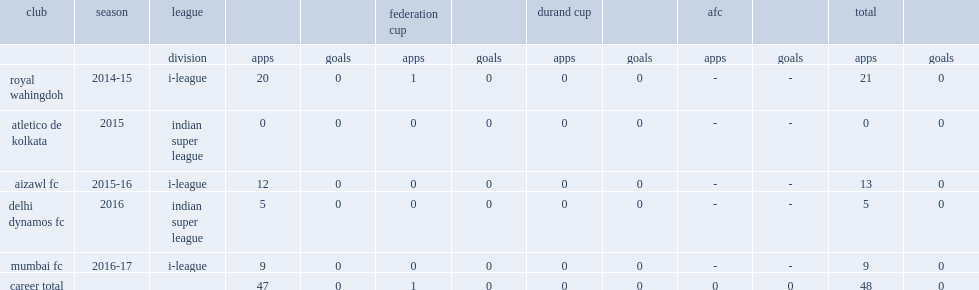Which club did lalchhawnkima play for in 2015? Atletico de kolkata. 